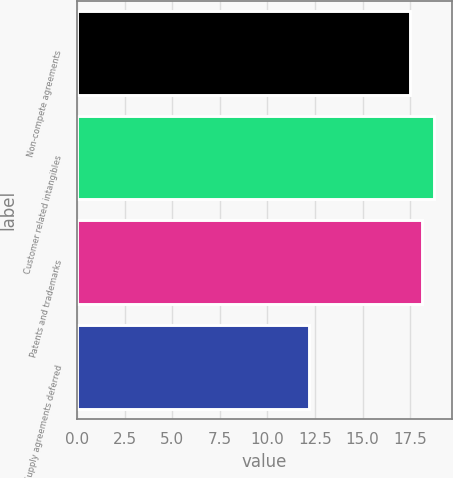<chart> <loc_0><loc_0><loc_500><loc_500><bar_chart><fcel>Non-compete agreements<fcel>Customer related intangibles<fcel>Patents and trademarks<fcel>Supply agreements deferred<nl><fcel>17.5<fcel>18.76<fcel>18.13<fcel>12.2<nl></chart> 